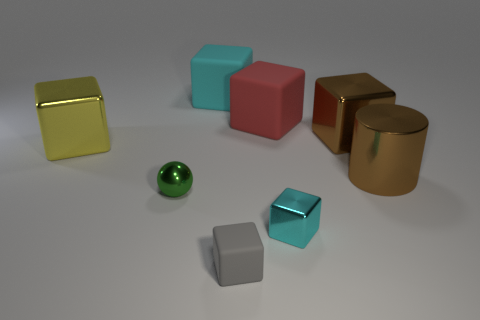Looking at the arrangement, is there a pattern or theme to the way these objects are placed? The arrangement of objects in the image doesn't seem to follow a specific discernible pattern, but it does create a visually pleasing composition. The objects are spaced out evenly, with no apparent order to their placement. This randomness, combined with the variety in color and finish—matte, shiny, and metallic—gives the impression of a scene set for a study on form, texture, and light interaction. 